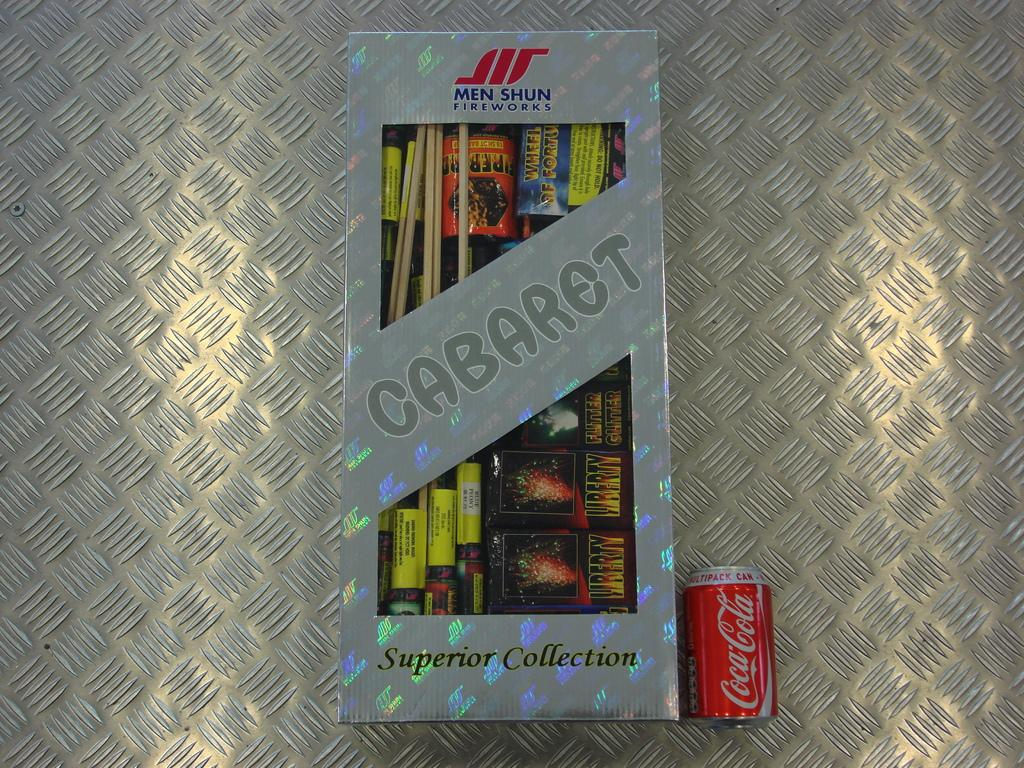<image>
Describe the image concisely. A box of superior collection fireworks next to a Coca-Cola can. 